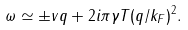Convert formula to latex. <formula><loc_0><loc_0><loc_500><loc_500>\omega \simeq \pm v q + 2 i \pi \gamma T ( q / k _ { F } ) ^ { 2 } .</formula> 